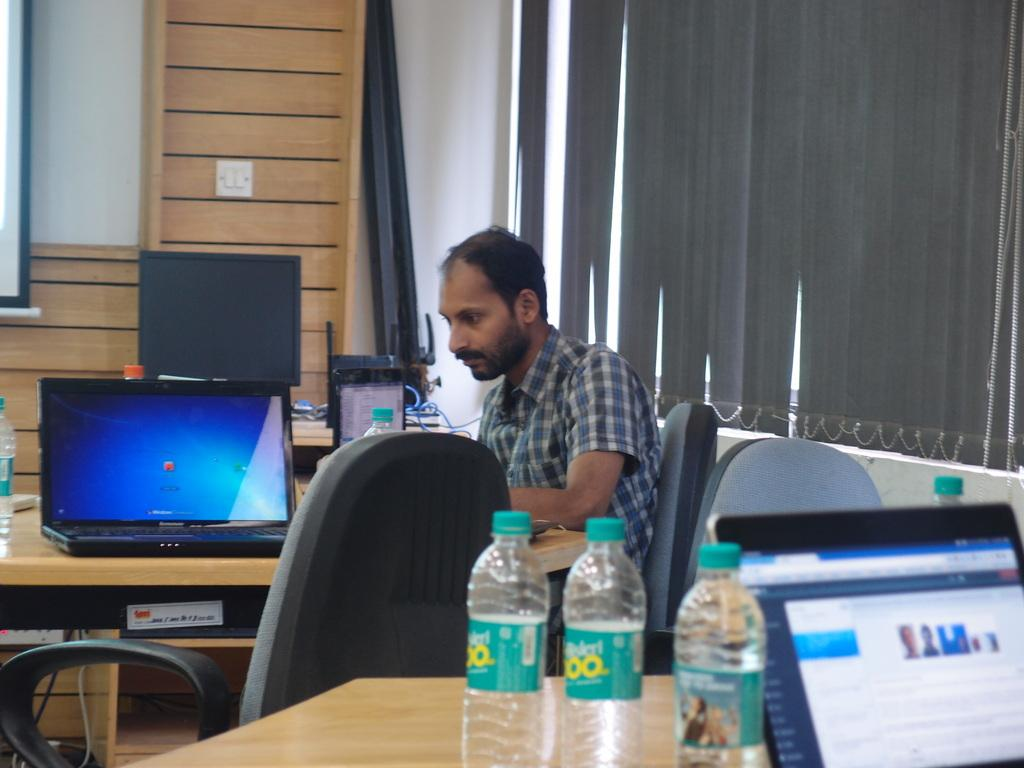Who is present in the image? There is a man in the image. What is the man doing in the image? The man is sitting on a chair. What is on the table in front of the man? There is a laptop and bottles on the table. What can be seen in the background of the image? The background includes windows and a wooden wall. What type of soup is being served in the image? There is no soup present in the image. What is the man's chance of winning the lottery based on the image? The image does not provide any information about the man's chances of winning the lottery. 